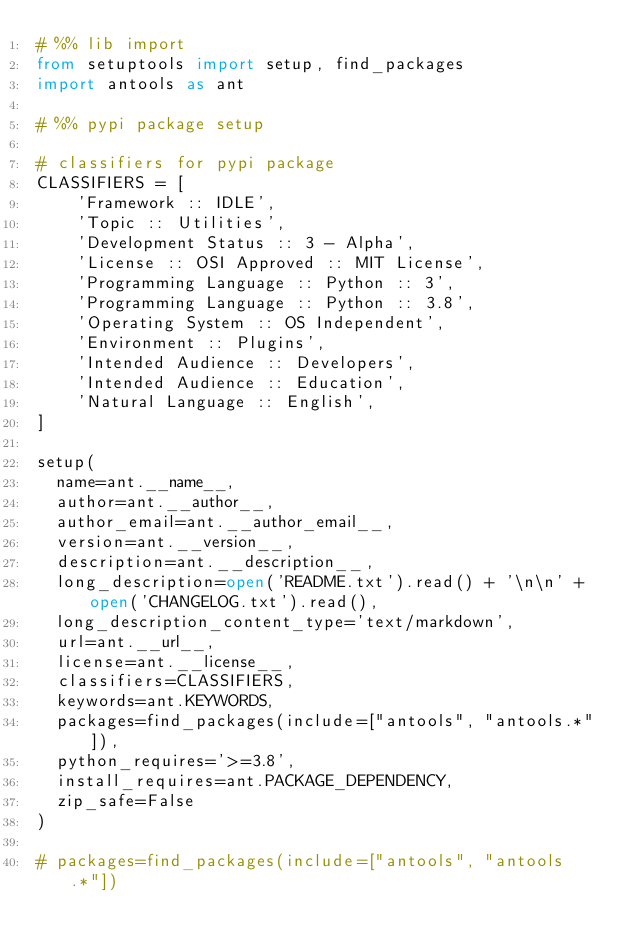<code> <loc_0><loc_0><loc_500><loc_500><_Python_># %% lib import
from setuptools import setup, find_packages
import antools as ant

# %% pypi package setup

# classifiers for pypi package
CLASSIFIERS = [
    'Framework :: IDLE',
    'Topic :: Utilities',
    'Development Status :: 3 - Alpha',
    'License :: OSI Approved :: MIT License',
    'Programming Language :: Python :: 3',
    'Programming Language :: Python :: 3.8',
    'Operating System :: OS Independent',
    'Environment :: Plugins',
    'Intended Audience :: Developers',
    'Intended Audience :: Education',
    'Natural Language :: English',
]

setup(
  name=ant.__name__,
  author=ant.__author__,
  author_email=ant.__author_email__,  
  version=ant.__version__,  
  description=ant.__description__,  
  long_description=open('README.txt').read() + '\n\n' + open('CHANGELOG.txt').read(),
  long_description_content_type='text/markdown',
  url=ant.__url__,  
  license=ant.__license__, 
  classifiers=CLASSIFIERS,
  keywords=ant.KEYWORDS, 
  packages=find_packages(include=["antools", "antools.*"]),
  python_requires='>=3.8',
  install_requires=ant.PACKAGE_DEPENDENCY,
  zip_safe=False
)

# packages=find_packages(include=["antools", "antools.*"])</code> 